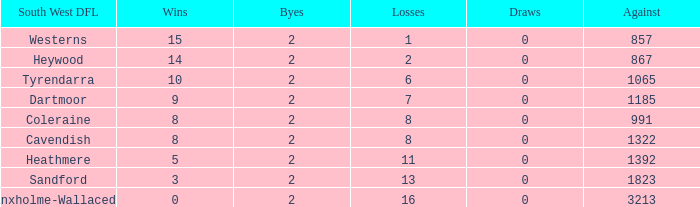What are the losses that have a south west dfl in branxholme-wallacedale and fewer than 2 byes? None. 